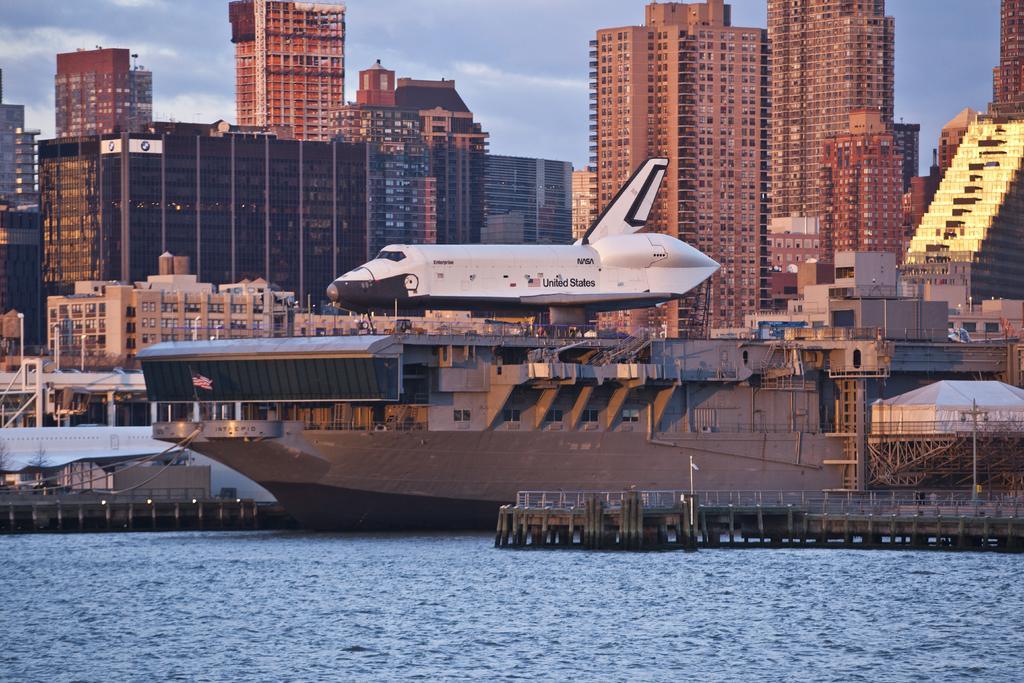Could you give a brief overview of what you see in this image? In this image in the middle, there is a boat on that there is an aeroplane. At the bottom there is water. In the background there are buildings, electric poles, sky and clouds. 